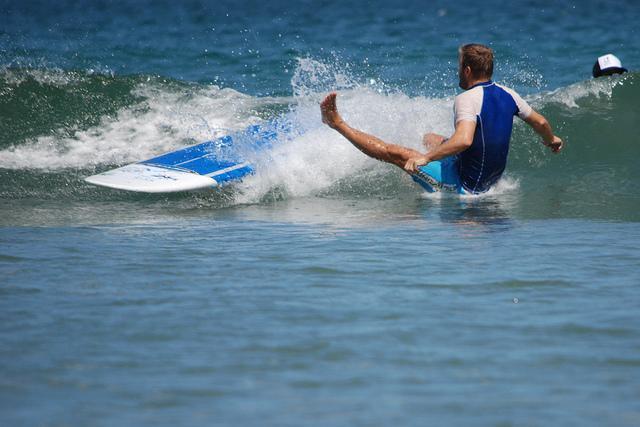How many baby zebras are there?
Give a very brief answer. 0. 